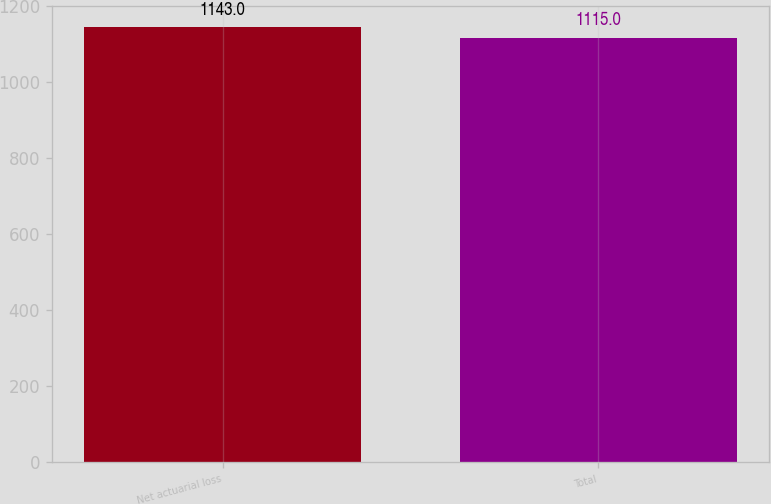Convert chart to OTSL. <chart><loc_0><loc_0><loc_500><loc_500><bar_chart><fcel>Net actuarial loss<fcel>Total<nl><fcel>1143<fcel>1115<nl></chart> 